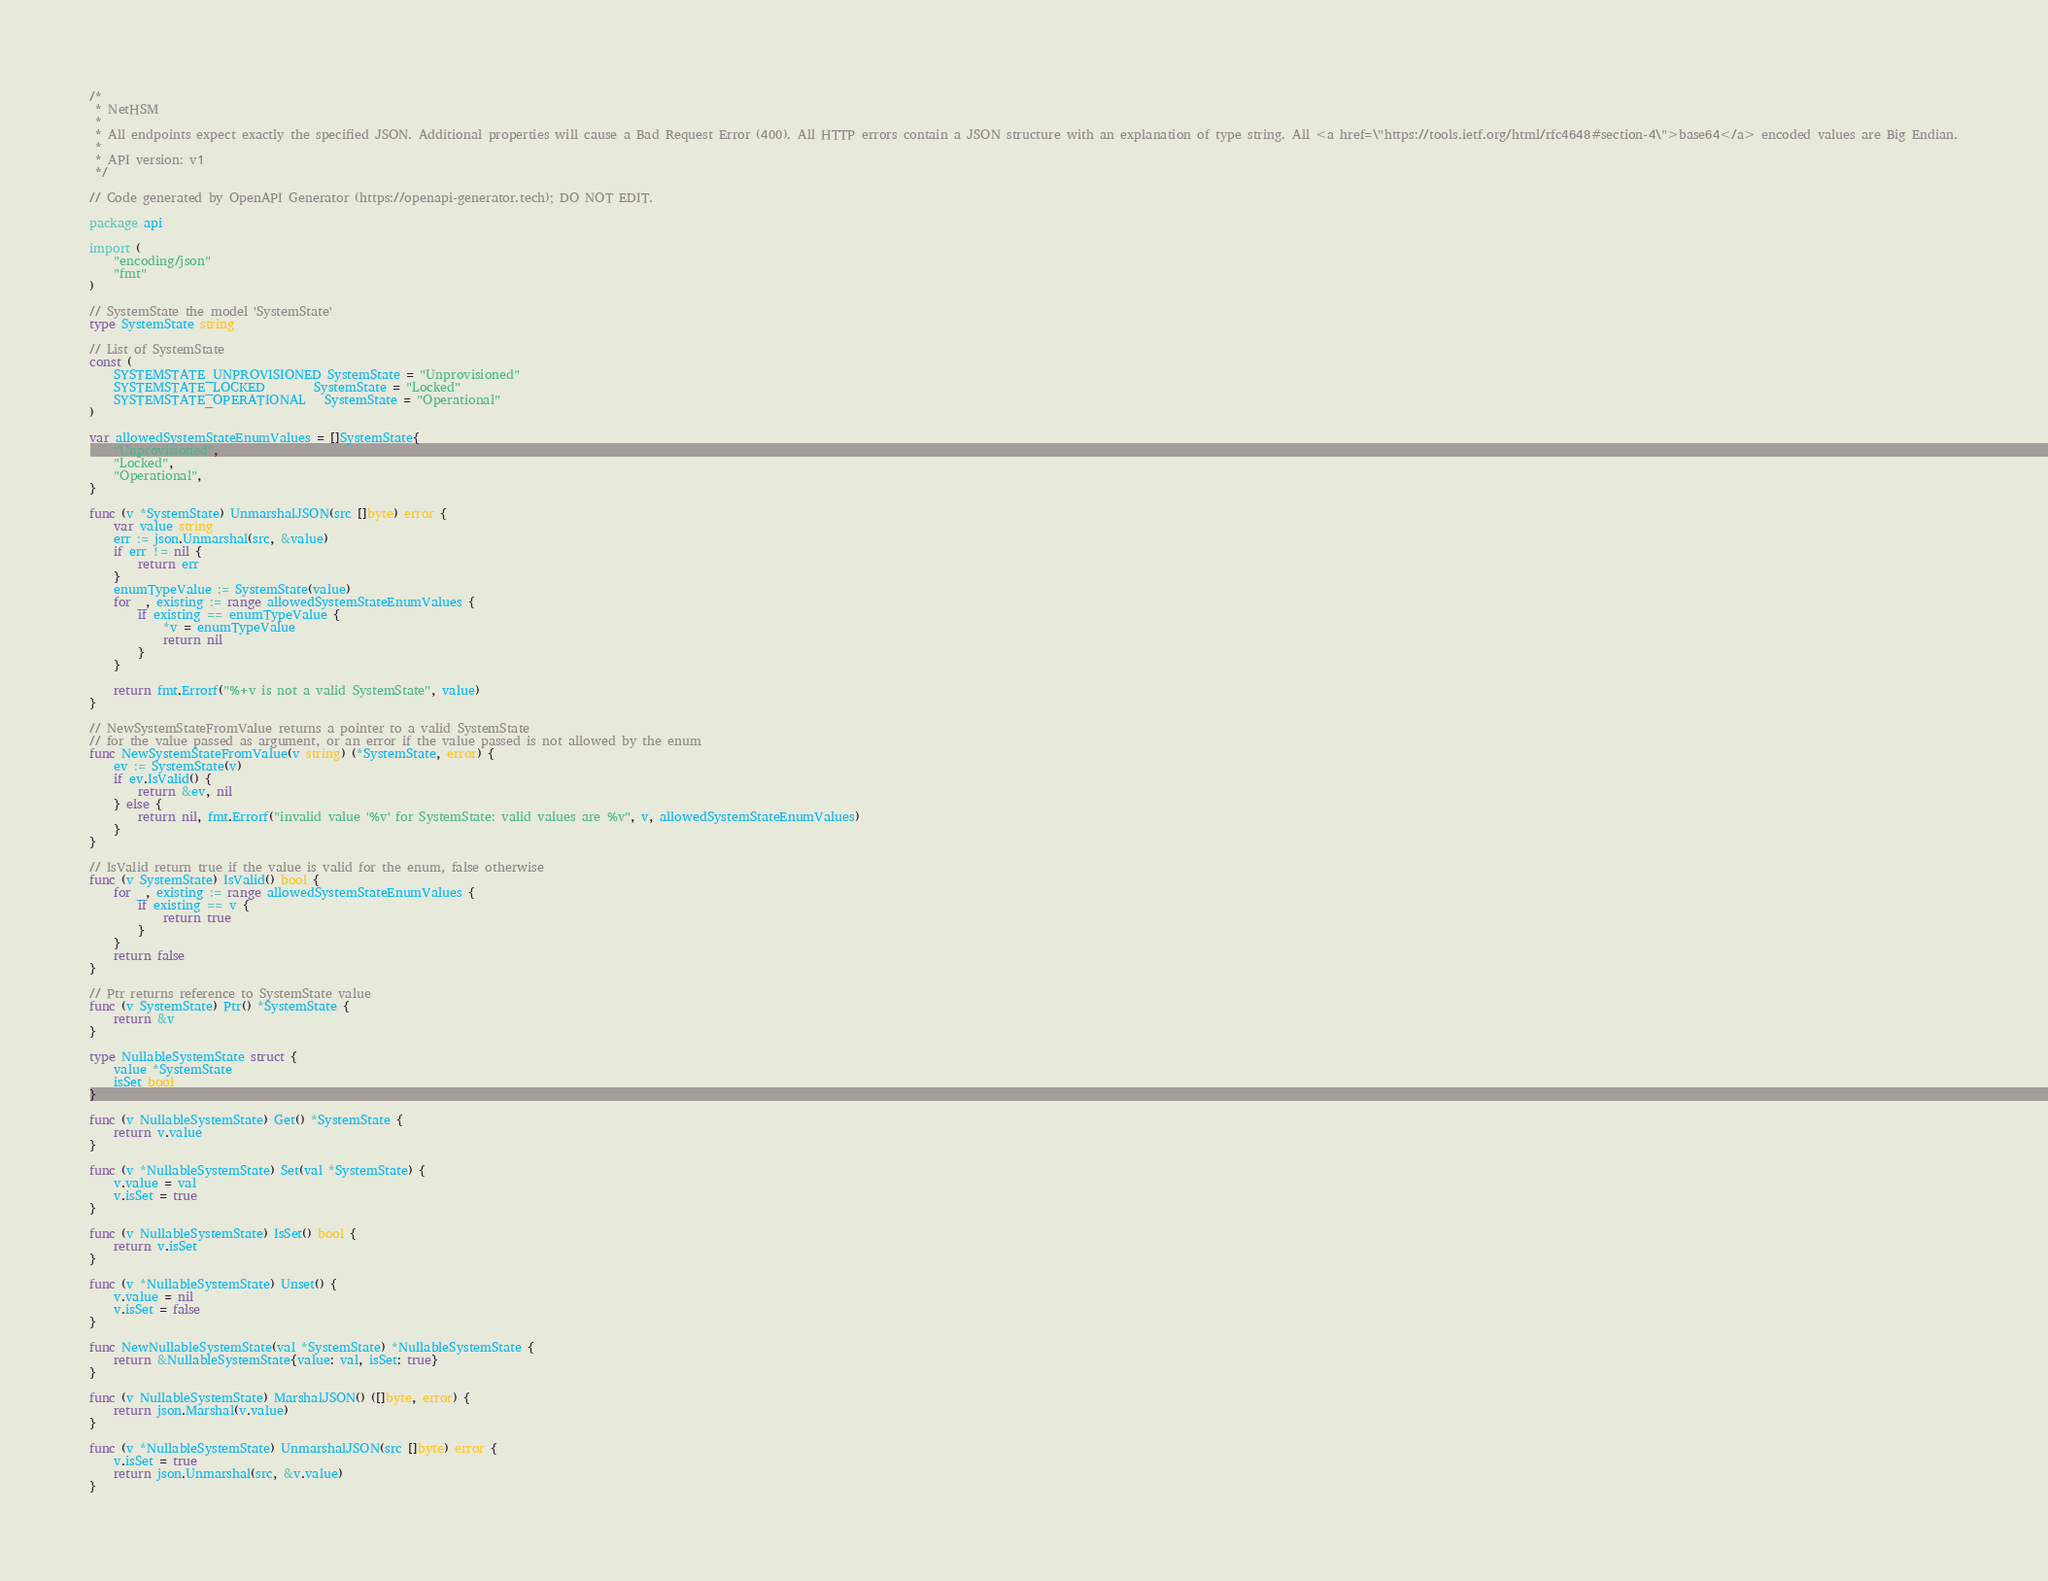<code> <loc_0><loc_0><loc_500><loc_500><_Go_>/*
 * NetHSM
 *
 * All endpoints expect exactly the specified JSON. Additional properties will cause a Bad Request Error (400). All HTTP errors contain a JSON structure with an explanation of type string. All <a href=\"https://tools.ietf.org/html/rfc4648#section-4\">base64</a> encoded values are Big Endian.
 *
 * API version: v1
 */

// Code generated by OpenAPI Generator (https://openapi-generator.tech); DO NOT EDIT.

package api

import (
	"encoding/json"
	"fmt"
)

// SystemState the model 'SystemState'
type SystemState string

// List of SystemState
const (
	SYSTEMSTATE_UNPROVISIONED SystemState = "Unprovisioned"
	SYSTEMSTATE_LOCKED        SystemState = "Locked"
	SYSTEMSTATE_OPERATIONAL   SystemState = "Operational"
)

var allowedSystemStateEnumValues = []SystemState{
	"Unprovisioned",
	"Locked",
	"Operational",
}

func (v *SystemState) UnmarshalJSON(src []byte) error {
	var value string
	err := json.Unmarshal(src, &value)
	if err != nil {
		return err
	}
	enumTypeValue := SystemState(value)
	for _, existing := range allowedSystemStateEnumValues {
		if existing == enumTypeValue {
			*v = enumTypeValue
			return nil
		}
	}

	return fmt.Errorf("%+v is not a valid SystemState", value)
}

// NewSystemStateFromValue returns a pointer to a valid SystemState
// for the value passed as argument, or an error if the value passed is not allowed by the enum
func NewSystemStateFromValue(v string) (*SystemState, error) {
	ev := SystemState(v)
	if ev.IsValid() {
		return &ev, nil
	} else {
		return nil, fmt.Errorf("invalid value '%v' for SystemState: valid values are %v", v, allowedSystemStateEnumValues)
	}
}

// IsValid return true if the value is valid for the enum, false otherwise
func (v SystemState) IsValid() bool {
	for _, existing := range allowedSystemStateEnumValues {
		if existing == v {
			return true
		}
	}
	return false
}

// Ptr returns reference to SystemState value
func (v SystemState) Ptr() *SystemState {
	return &v
}

type NullableSystemState struct {
	value *SystemState
	isSet bool
}

func (v NullableSystemState) Get() *SystemState {
	return v.value
}

func (v *NullableSystemState) Set(val *SystemState) {
	v.value = val
	v.isSet = true
}

func (v NullableSystemState) IsSet() bool {
	return v.isSet
}

func (v *NullableSystemState) Unset() {
	v.value = nil
	v.isSet = false
}

func NewNullableSystemState(val *SystemState) *NullableSystemState {
	return &NullableSystemState{value: val, isSet: true}
}

func (v NullableSystemState) MarshalJSON() ([]byte, error) {
	return json.Marshal(v.value)
}

func (v *NullableSystemState) UnmarshalJSON(src []byte) error {
	v.isSet = true
	return json.Unmarshal(src, &v.value)
}
</code> 